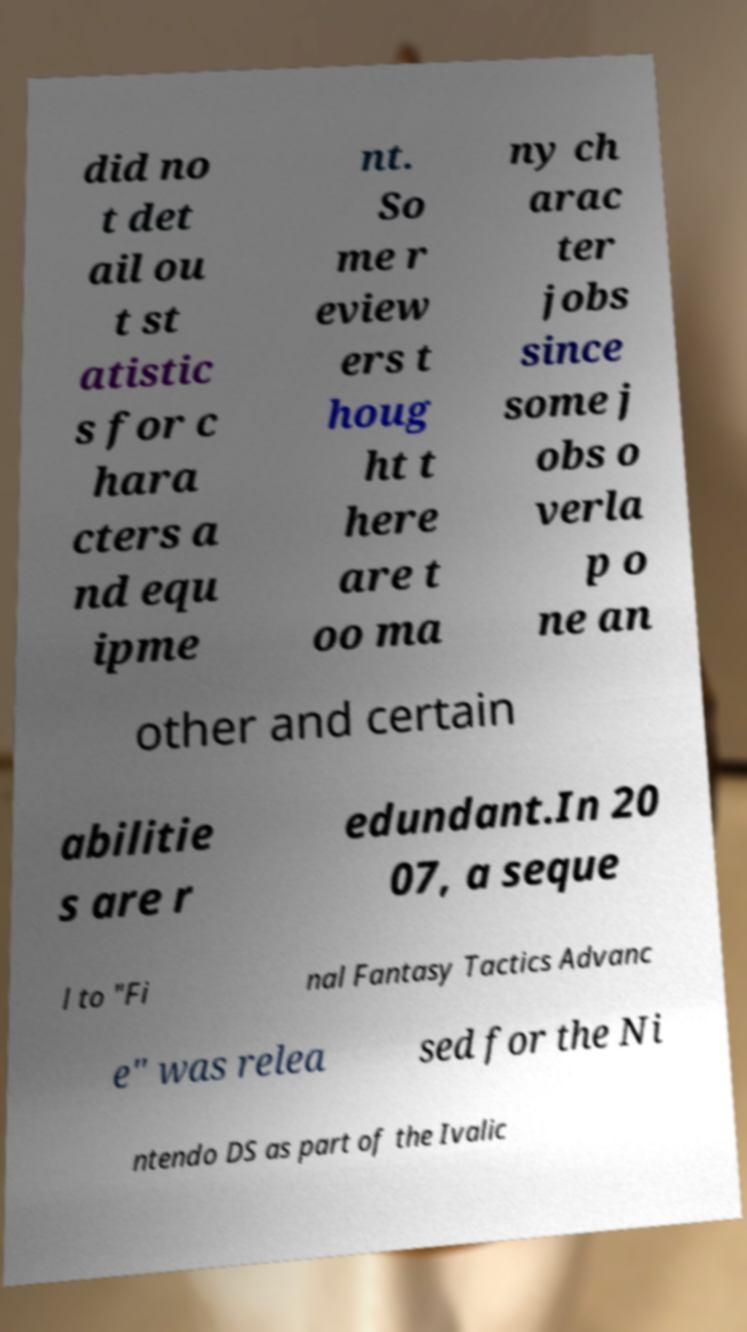What messages or text are displayed in this image? I need them in a readable, typed format. did no t det ail ou t st atistic s for c hara cters a nd equ ipme nt. So me r eview ers t houg ht t here are t oo ma ny ch arac ter jobs since some j obs o verla p o ne an other and certain abilitie s are r edundant.In 20 07, a seque l to "Fi nal Fantasy Tactics Advanc e" was relea sed for the Ni ntendo DS as part of the Ivalic 